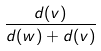Convert formula to latex. <formula><loc_0><loc_0><loc_500><loc_500>\frac { d ( v ) } { d ( w ) + d ( v ) }</formula> 